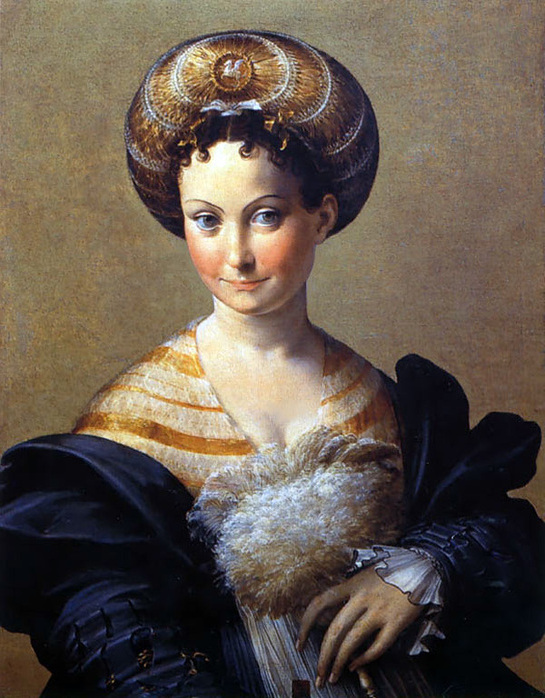What are the key elements in this picture? The image portrays a woman, captured in the distinct style of the Italian Renaissance. She is the central figure, her visage rendered in meticulous detail, indicative of the oil medium used. Her attire is elaborate, featuring a striped dress adorned with a fur collar, over which she wears a black shawl. The dress, coupled with the large headdress decorated with a gold and pearl brooch, suggests a person of high status or nobility. The background is a plain, beige color, serving to highlight the woman and her attire. The overall composition and style are reminiscent of the portraiture common in the Renaissance period, characterized by a focus on realism and detail. 